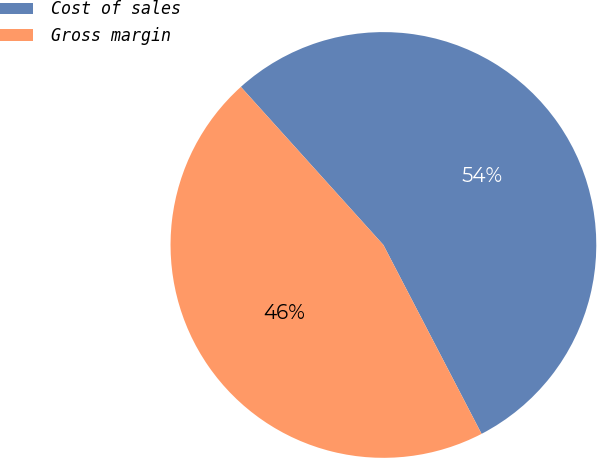<chart> <loc_0><loc_0><loc_500><loc_500><pie_chart><fcel>Cost of sales<fcel>Gross margin<nl><fcel>54.05%<fcel>45.95%<nl></chart> 